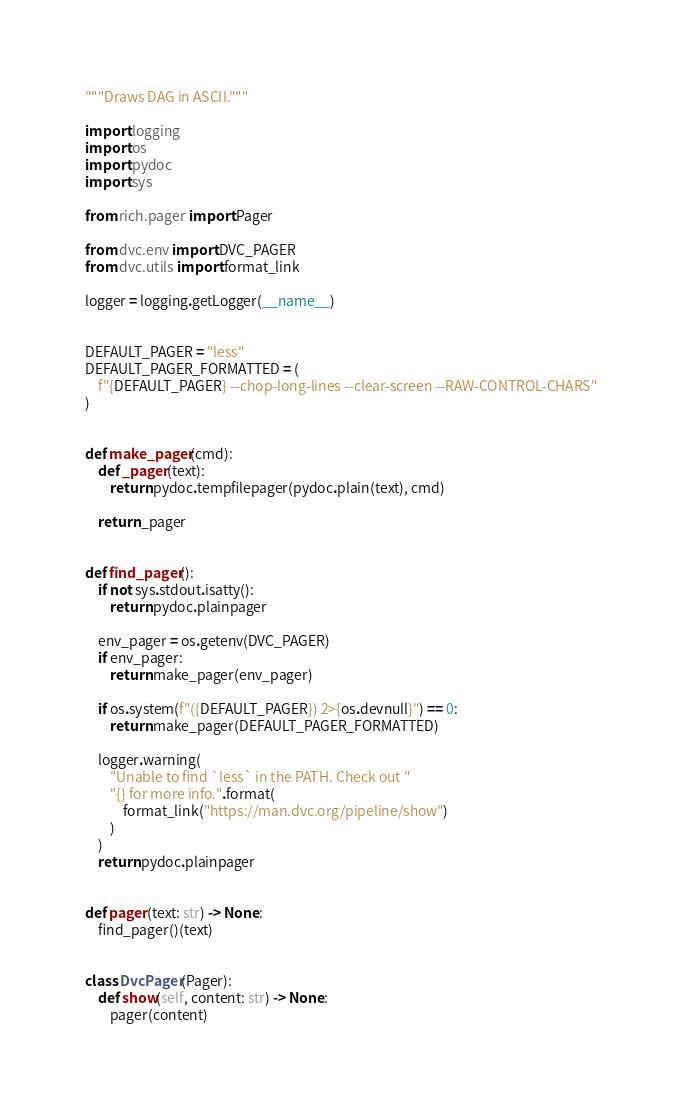<code> <loc_0><loc_0><loc_500><loc_500><_Python_>"""Draws DAG in ASCII."""

import logging
import os
import pydoc
import sys

from rich.pager import Pager

from dvc.env import DVC_PAGER
from dvc.utils import format_link

logger = logging.getLogger(__name__)


DEFAULT_PAGER = "less"
DEFAULT_PAGER_FORMATTED = (
    f"{DEFAULT_PAGER} --chop-long-lines --clear-screen --RAW-CONTROL-CHARS"
)


def make_pager(cmd):
    def _pager(text):
        return pydoc.tempfilepager(pydoc.plain(text), cmd)

    return _pager


def find_pager():
    if not sys.stdout.isatty():
        return pydoc.plainpager

    env_pager = os.getenv(DVC_PAGER)
    if env_pager:
        return make_pager(env_pager)

    if os.system(f"({DEFAULT_PAGER}) 2>{os.devnull}") == 0:
        return make_pager(DEFAULT_PAGER_FORMATTED)

    logger.warning(
        "Unable to find `less` in the PATH. Check out "
        "{} for more info.".format(
            format_link("https://man.dvc.org/pipeline/show")
        )
    )
    return pydoc.plainpager


def pager(text: str) -> None:
    find_pager()(text)


class DvcPager(Pager):
    def show(self, content: str) -> None:
        pager(content)
</code> 